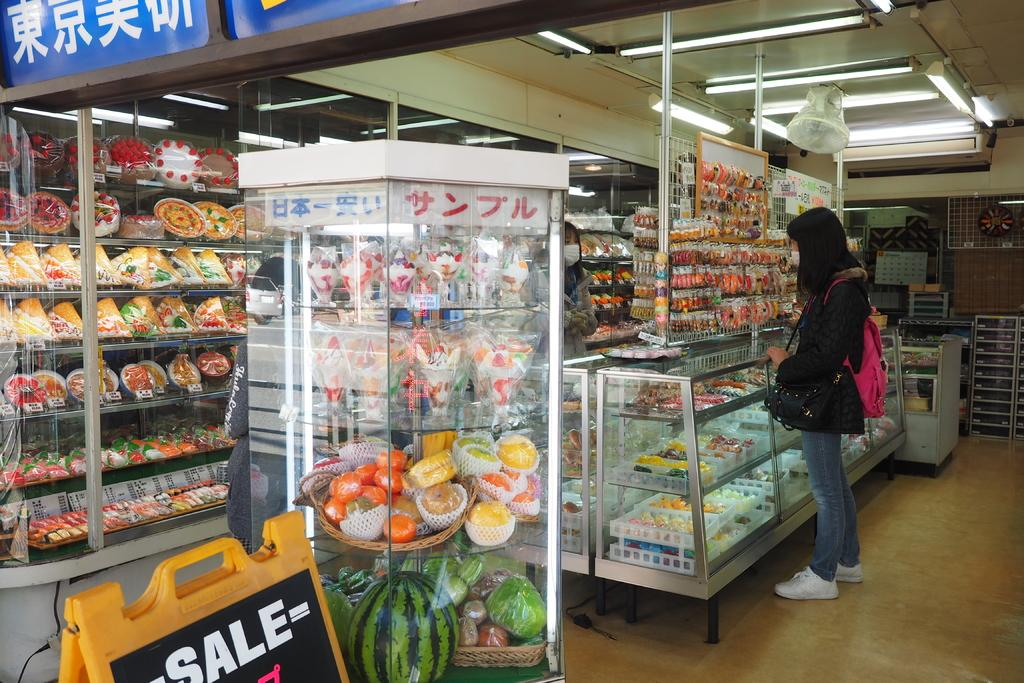<image>
Offer a succinct explanation of the picture presented. A woman standing next to a food display with a "SALE" sign nearby 